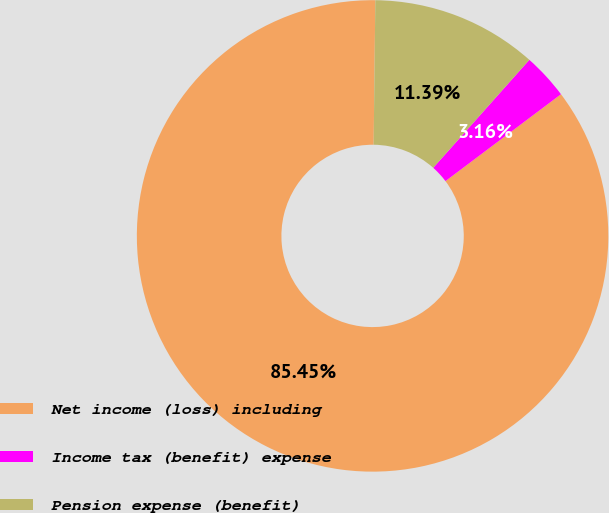Convert chart. <chart><loc_0><loc_0><loc_500><loc_500><pie_chart><fcel>Net income (loss) including<fcel>Income tax (benefit) expense<fcel>Pension expense (benefit)<nl><fcel>85.44%<fcel>3.16%<fcel>11.39%<nl></chart> 